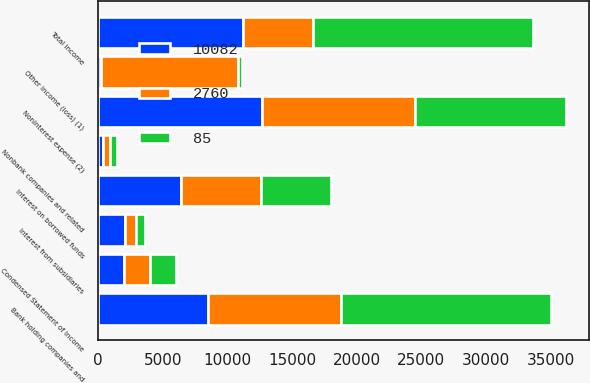Convert chart to OTSL. <chart><loc_0><loc_0><loc_500><loc_500><stacked_bar_chart><ecel><fcel>Condensed Statement of Income<fcel>Bank holding companies and<fcel>Nonbank companies and related<fcel>Interest from subsidiaries<fcel>Other income (loss) (1)<fcel>Total income<fcel>Interest on borrowed funds<fcel>Noninterest expense (2)<nl><fcel>10082<fcel>2013<fcel>8532<fcel>357<fcel>2087<fcel>233<fcel>11209<fcel>6379<fcel>12668<nl><fcel>85<fcel>2012<fcel>16213<fcel>542<fcel>627<fcel>304<fcel>17078<fcel>5376<fcel>11643<nl><fcel>2760<fcel>2011<fcel>10277<fcel>553<fcel>869<fcel>10603<fcel>5376<fcel>6234<fcel>11861<nl></chart> 